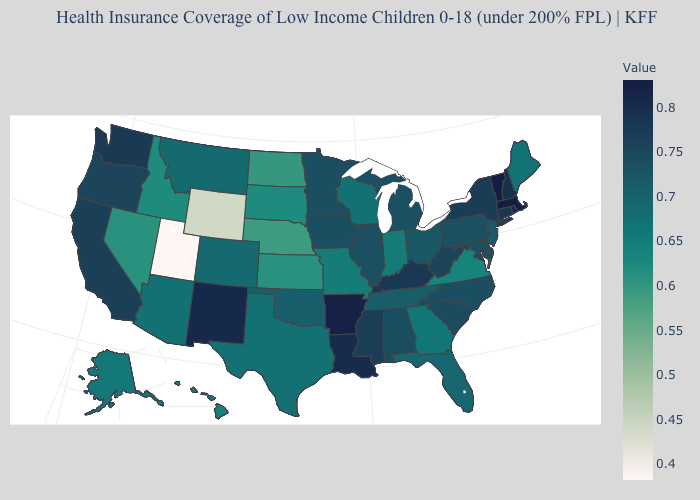Does the map have missing data?
Keep it brief. No. Does the map have missing data?
Write a very short answer. No. Among the states that border New Mexico , does Colorado have the lowest value?
Give a very brief answer. No. Which states have the highest value in the USA?
Concise answer only. Massachusetts. Does Connecticut have the lowest value in the USA?
Answer briefly. No. 